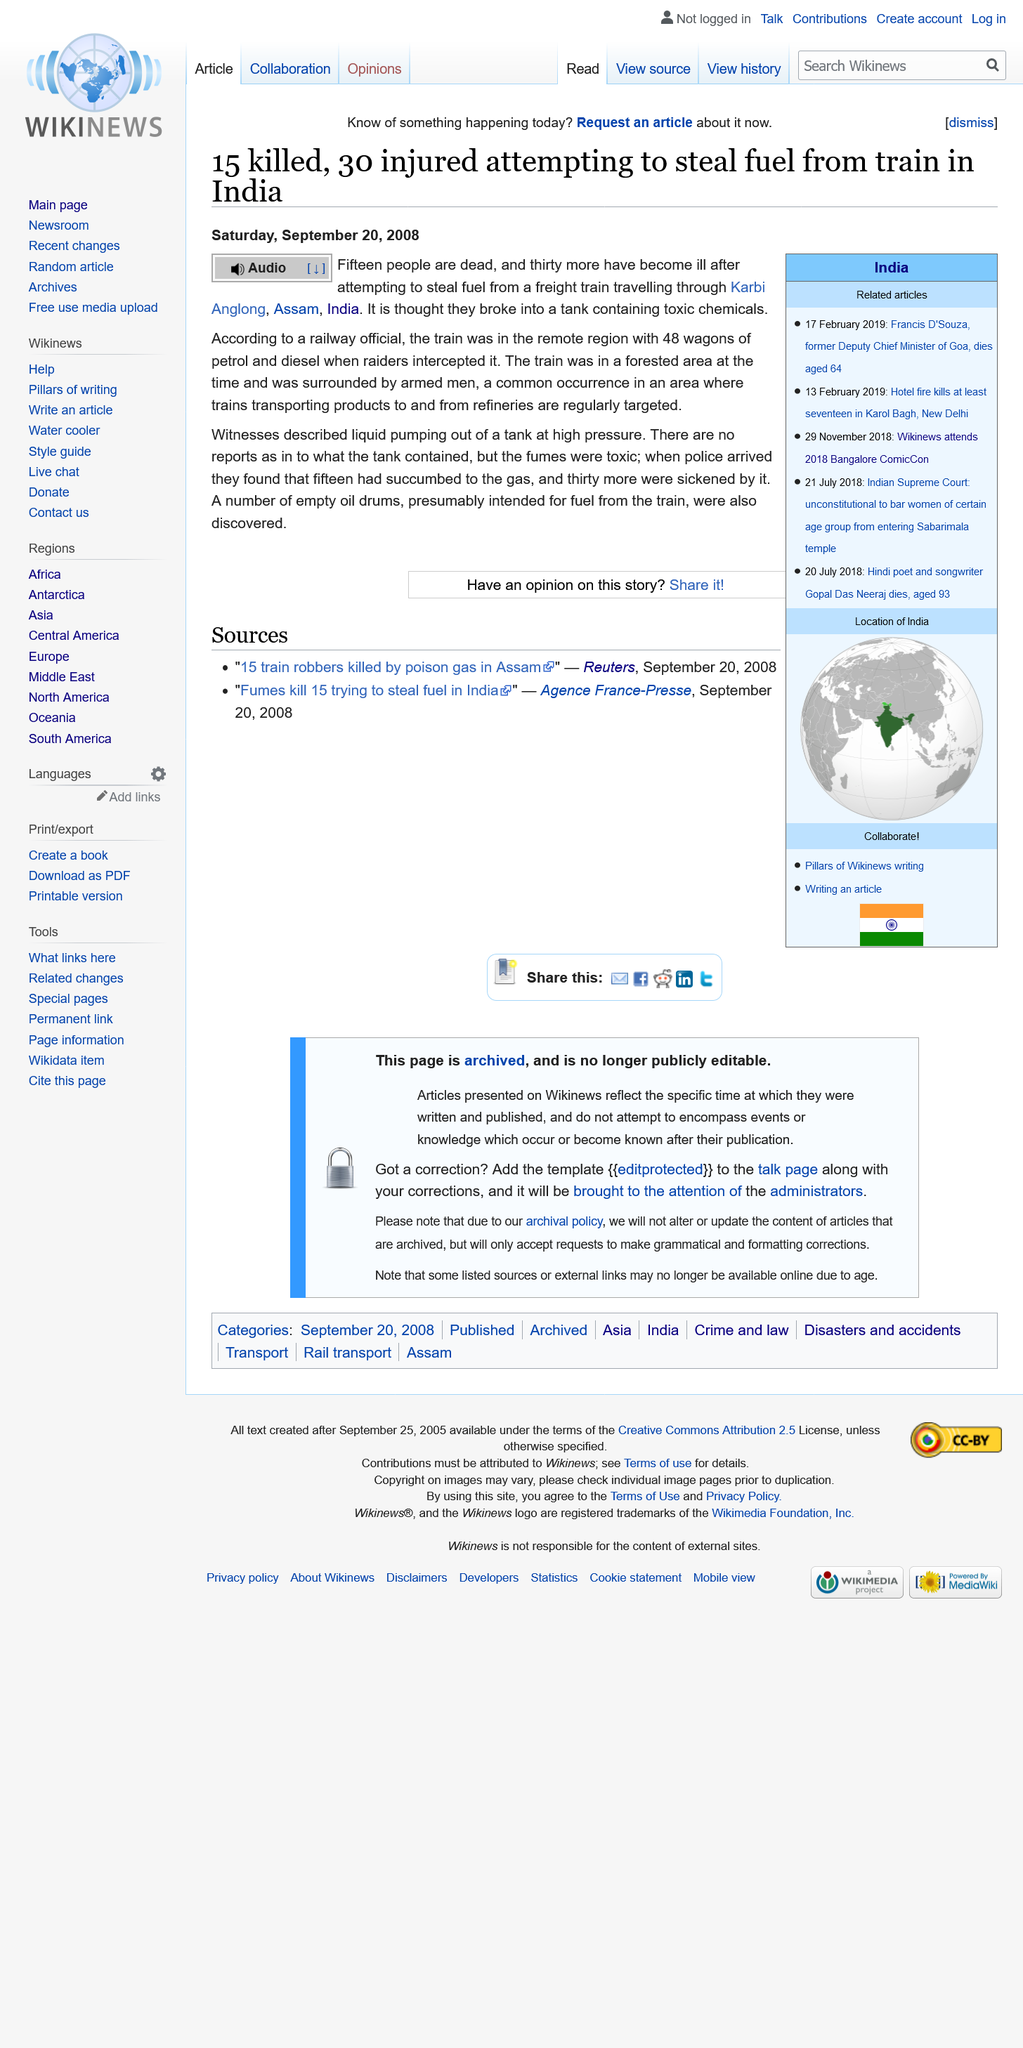Highlight a few significant elements in this photo. India is the country where the area of Karbi is located. Fifteen individuals have succumbed to their demises. At the time, the train was in a forested area. 